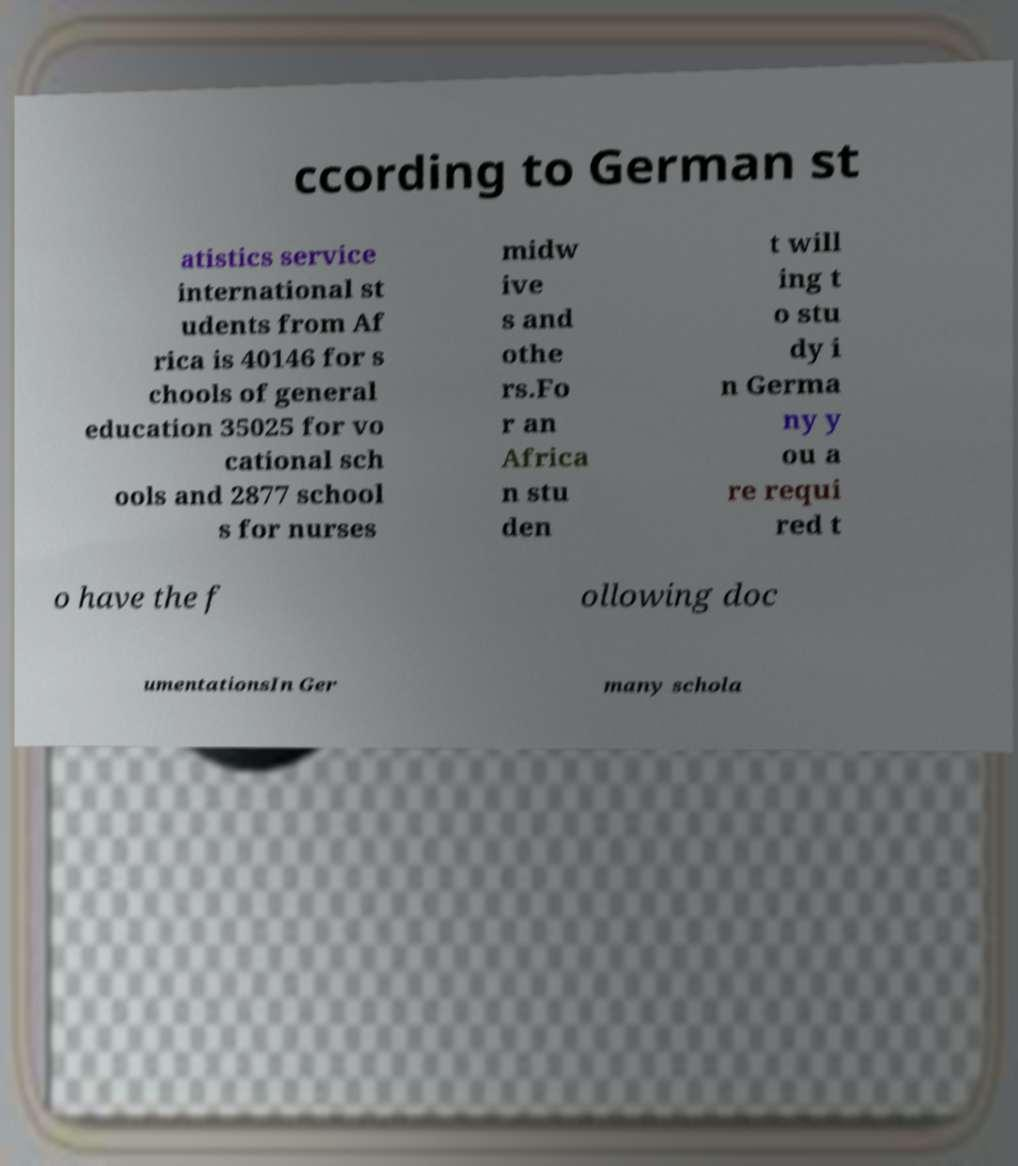Please read and relay the text visible in this image. What does it say? ccording to German st atistics service international st udents from Af rica is 40146 for s chools of general education 35025 for vo cational sch ools and 2877 school s for nurses midw ive s and othe rs.Fo r an Africa n stu den t will ing t o stu dy i n Germa ny y ou a re requi red t o have the f ollowing doc umentationsIn Ger many schola 